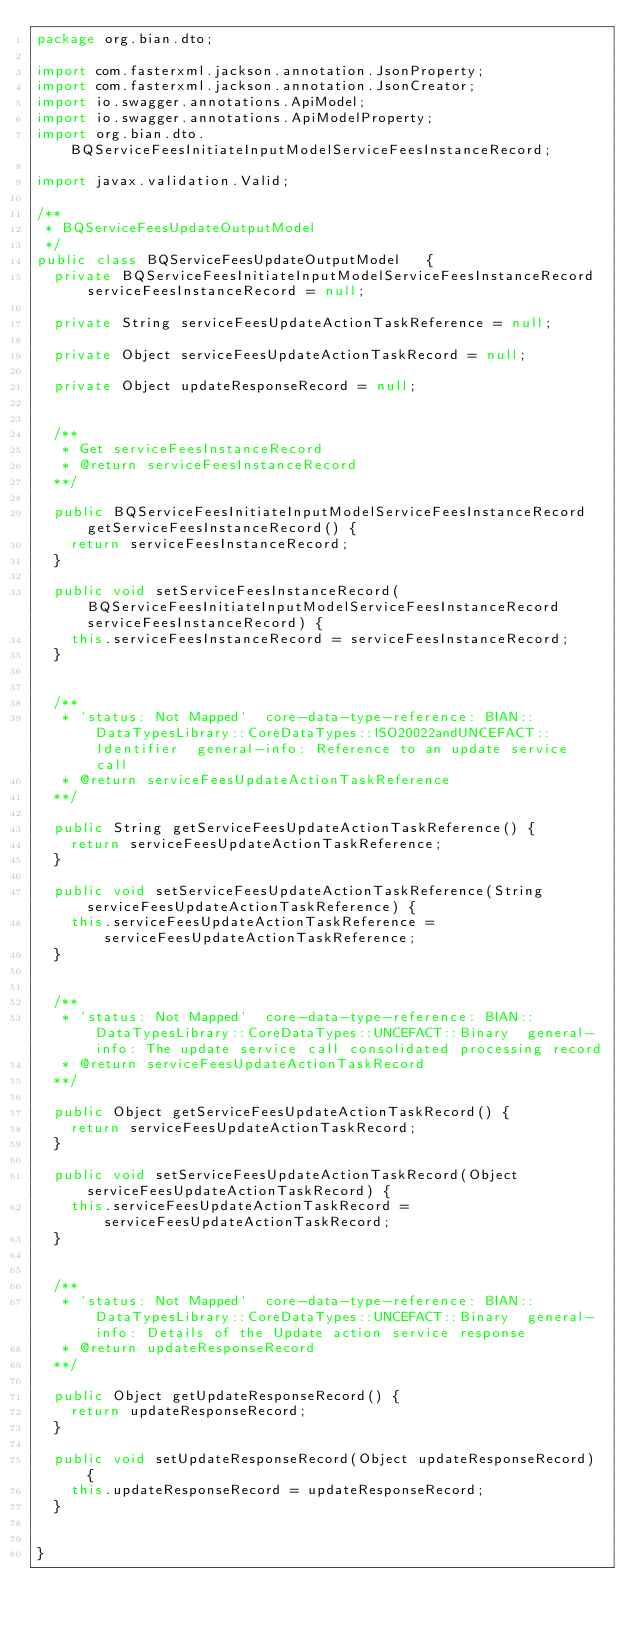<code> <loc_0><loc_0><loc_500><loc_500><_Java_>package org.bian.dto;

import com.fasterxml.jackson.annotation.JsonProperty;
import com.fasterxml.jackson.annotation.JsonCreator;
import io.swagger.annotations.ApiModel;
import io.swagger.annotations.ApiModelProperty;
import org.bian.dto.BQServiceFeesInitiateInputModelServiceFeesInstanceRecord;

import javax.validation.Valid;
  
/**
 * BQServiceFeesUpdateOutputModel
 */
public class BQServiceFeesUpdateOutputModel   {
  private BQServiceFeesInitiateInputModelServiceFeesInstanceRecord serviceFeesInstanceRecord = null;

  private String serviceFeesUpdateActionTaskReference = null;

  private Object serviceFeesUpdateActionTaskRecord = null;

  private Object updateResponseRecord = null;


  /**
   * Get serviceFeesInstanceRecord
   * @return serviceFeesInstanceRecord
  **/

  public BQServiceFeesInitiateInputModelServiceFeesInstanceRecord getServiceFeesInstanceRecord() {
    return serviceFeesInstanceRecord;
  }

  public void setServiceFeesInstanceRecord(BQServiceFeesInitiateInputModelServiceFeesInstanceRecord serviceFeesInstanceRecord) {
    this.serviceFeesInstanceRecord = serviceFeesInstanceRecord;
  }


  /**
   * `status: Not Mapped`  core-data-type-reference: BIAN::DataTypesLibrary::CoreDataTypes::ISO20022andUNCEFACT::Identifier  general-info: Reference to an update service call 
   * @return serviceFeesUpdateActionTaskReference
  **/

  public String getServiceFeesUpdateActionTaskReference() {
    return serviceFeesUpdateActionTaskReference;
  }

  public void setServiceFeesUpdateActionTaskReference(String serviceFeesUpdateActionTaskReference) {
    this.serviceFeesUpdateActionTaskReference = serviceFeesUpdateActionTaskReference;
  }


  /**
   * `status: Not Mapped`  core-data-type-reference: BIAN::DataTypesLibrary::CoreDataTypes::UNCEFACT::Binary  general-info: The update service call consolidated processing record 
   * @return serviceFeesUpdateActionTaskRecord
  **/

  public Object getServiceFeesUpdateActionTaskRecord() {
    return serviceFeesUpdateActionTaskRecord;
  }

  public void setServiceFeesUpdateActionTaskRecord(Object serviceFeesUpdateActionTaskRecord) {
    this.serviceFeesUpdateActionTaskRecord = serviceFeesUpdateActionTaskRecord;
  }


  /**
   * `status: Not Mapped`  core-data-type-reference: BIAN::DataTypesLibrary::CoreDataTypes::UNCEFACT::Binary  general-info: Details of the Update action service response 
   * @return updateResponseRecord
  **/

  public Object getUpdateResponseRecord() {
    return updateResponseRecord;
  }

  public void setUpdateResponseRecord(Object updateResponseRecord) {
    this.updateResponseRecord = updateResponseRecord;
  }


}

</code> 